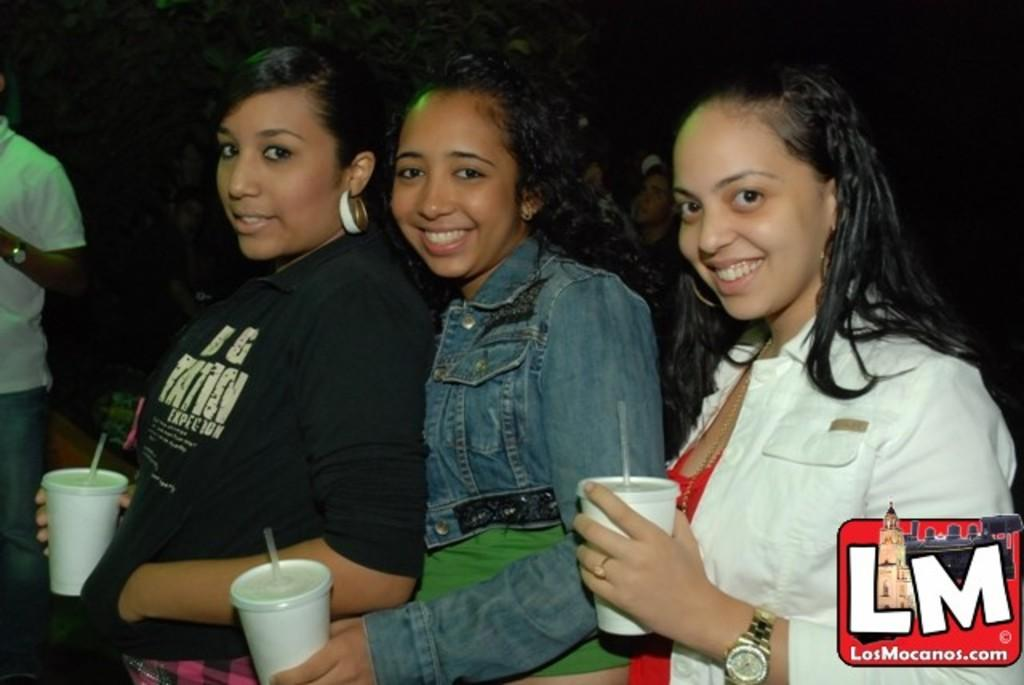How many women are in the image? There are three women in the image. What are the women doing in the image? The women are smiling and holding glasses. Can you describe the background of the image? There are people in the background of the image. What is present in the bottom right corner of the image? There is a logo in the bottom right corner of the image. What additional information is associated with the logo? There is some text associated with the logo. What type of flower is being used as a prop by one of the women in the image? There is no flower present in the image; the women are holding glasses. How does the ball affect the women's interaction in the image? There is no ball present in the image; the women are simply holding glasses and smiling. 